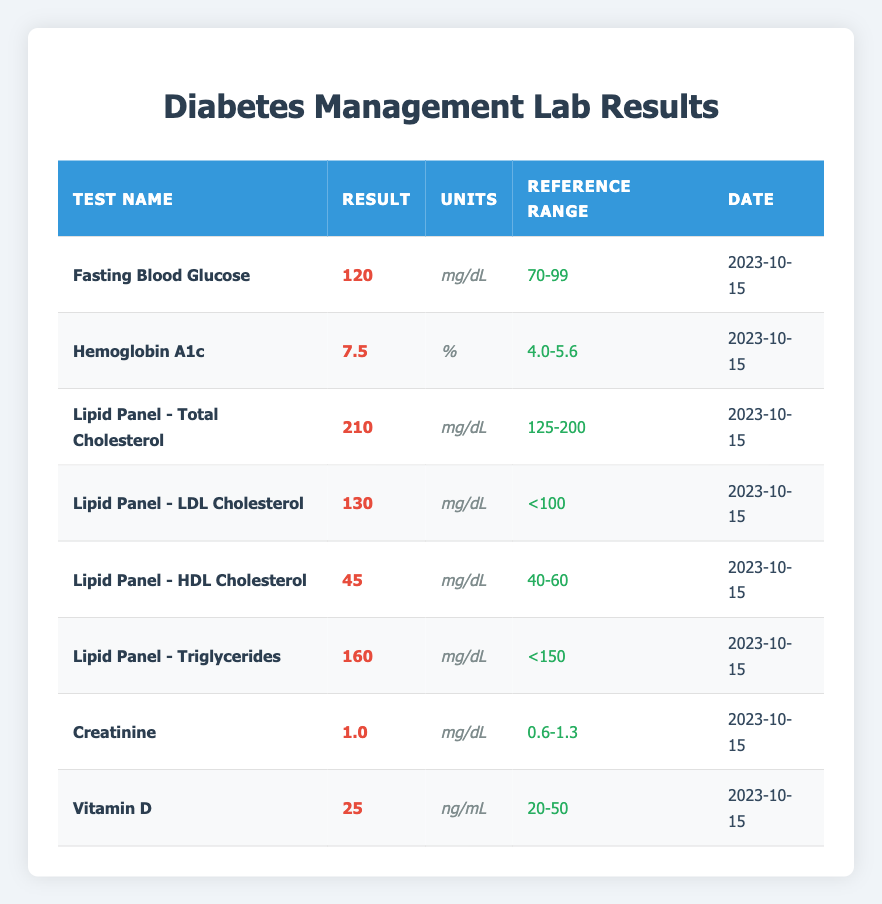What is the result value for Fasting Blood Glucose? According to the table, the result value for Fasting Blood Glucose is listed under the "Result" column, which shows a value of 120.
Answer: 120 Is the result for Hemoglobin A1c within the reference range? The reference range for Hemoglobin A1c is 4.0 to 5.6. The result is 7.5, which exceeds the upper limit of the reference range. Therefore, it is not within the range.
Answer: No What is the date for the Lipid Panel - Triglycerides test? The date is provided in the table under the "Date" column corresponding to the Lipid Panel - Triglycerides test, which is 2023-10-15.
Answer: 2023-10-15 What is the average result value of the Lipid Panel tests? The Lipid Panel tests have the following result values: Total Cholesterol (210), LDL Cholesterol (130), HDL Cholesterol (45), and Triglycerides (160). The average is calculated as (210 + 130 + 45 + 160) / 4 = 545 / 4 = 136.25.
Answer: 136.25 Is the Creatinine result within the reference range? The reference range for Creatinine is 0.6 to 1.3. The result is 1.0, which falls within this range, indicating it is acceptable.
Answer: Yes What is the highest result value among the tests listed in the table? By reviewing each test’s result value, the highest is found by comparing them: Fasting Blood Glucose (120), Hemoglobin A1c (7.5), Total Cholesterol (210), LDL (130), HDL (45), Triglycerides (160), Creatinine (1.0), Vitamin D (25). The highest is Total Cholesterol at 210.
Answer: 210 What is the difference between the Fasting Blood Glucose and the highest result value? The highest result value identified is Total Cholesterol (210), and the Fasting Blood Glucose result is 120. The difference is calculated by subtracting the Fasting Blood Glucose from the Total Cholesterol: 210 - 120 = 90.
Answer: 90 How many tests are reporting values that exceed the reference range? By examining the results and their respective reference ranges, the following tests exceed the reference range: Fasting Blood Glucose (120), Hemoglobin A1c (7.5), Total Cholesterol (210), and LDL Cholesterol (130). Therefore, there are four tests that exceed the reference range.
Answer: 4 What is the result value of HDL Cholesterol? The result value for HDL Cholesterol can be found directly in the table under the "Result" column, which indicates a value of 45.
Answer: 45 